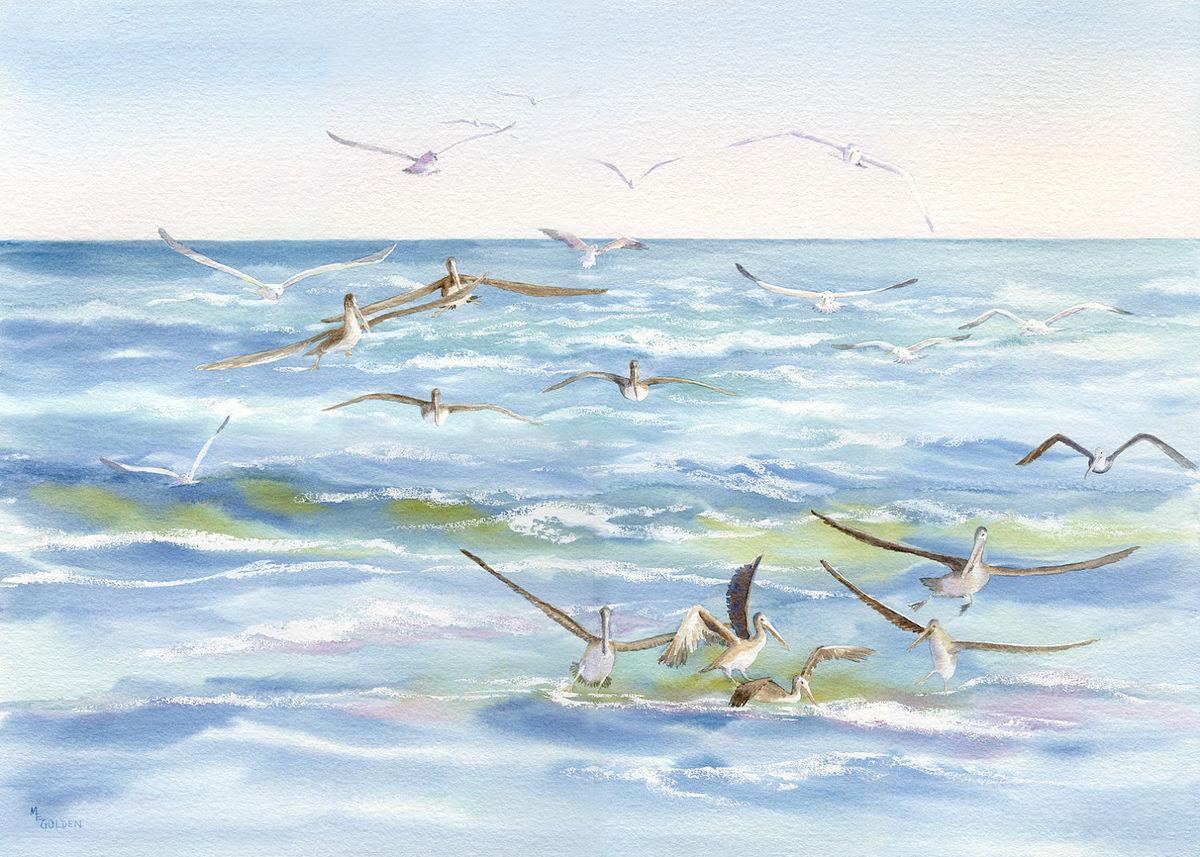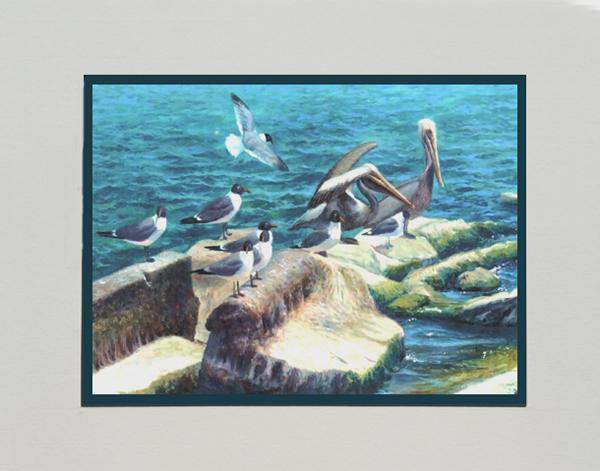The first image is the image on the left, the second image is the image on the right. Considering the images on both sides, is "One image includes a pelican and a smaller seabird perched on some part of a wooden pier." valid? Answer yes or no. No. The first image is the image on the left, the second image is the image on the right. Analyze the images presented: Is the assertion "A single pelican sits on a post in one of the image." valid? Answer yes or no. No. 